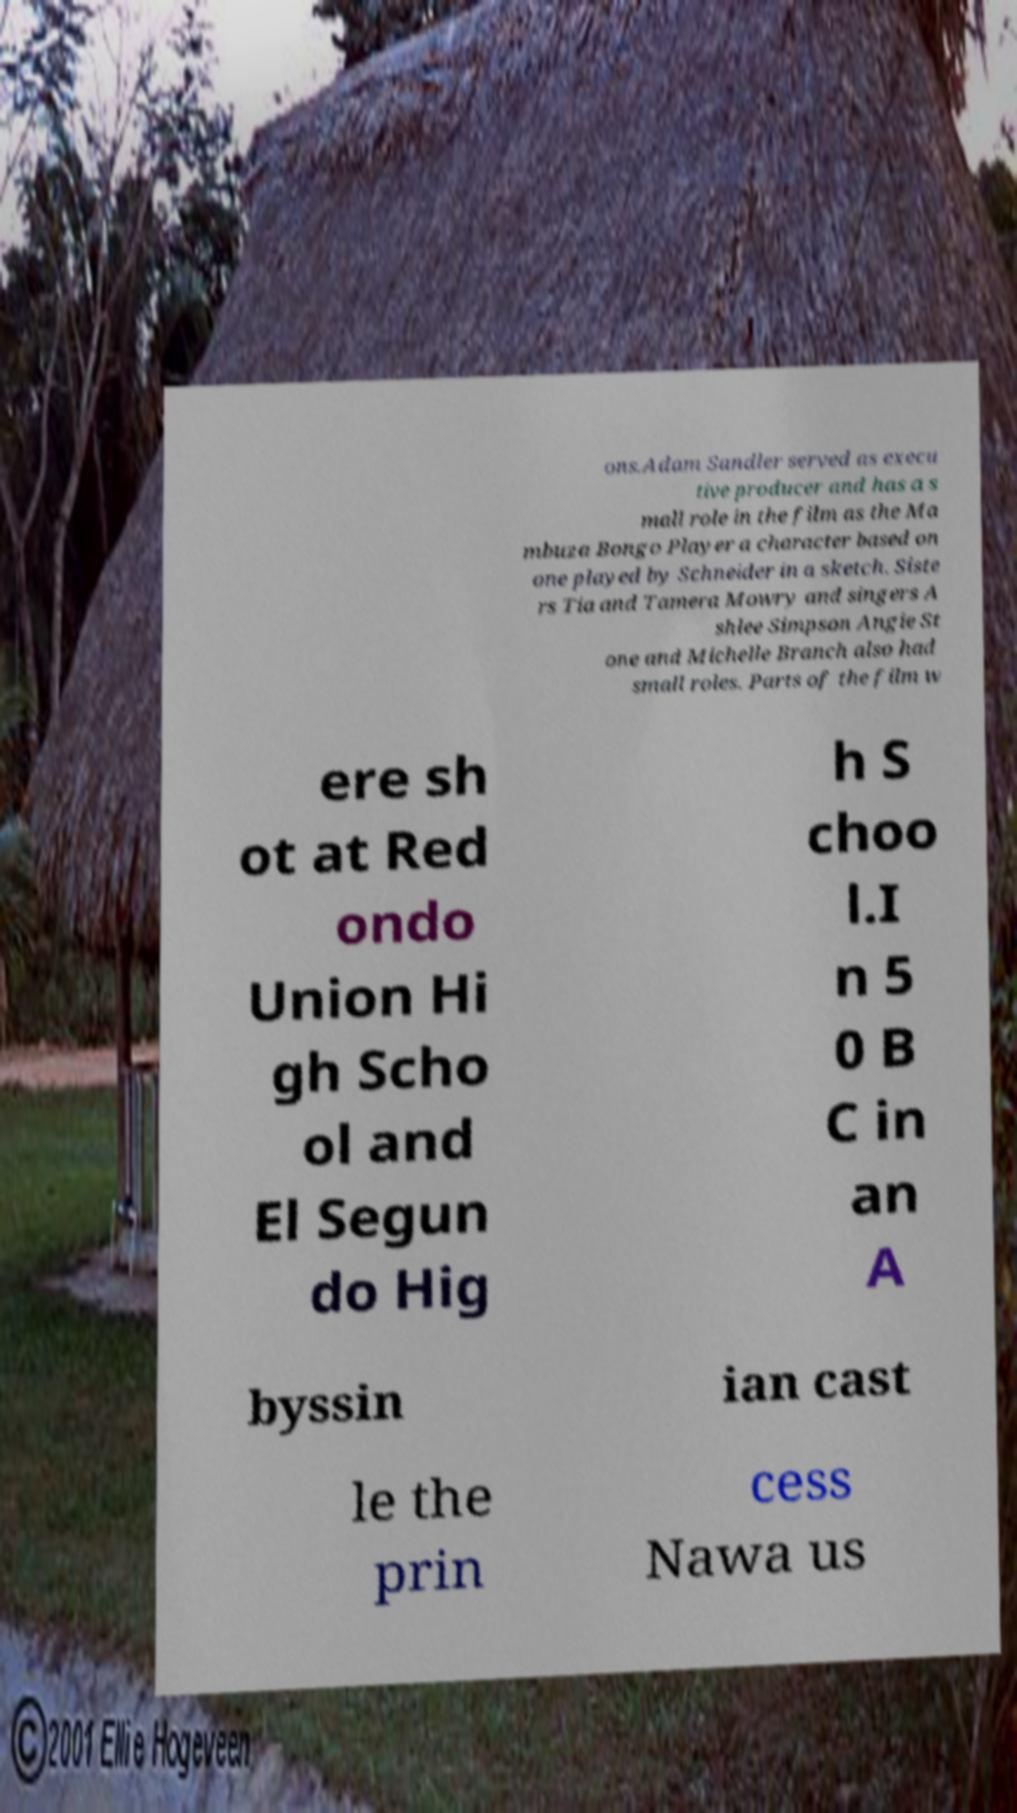Please identify and transcribe the text found in this image. ons.Adam Sandler served as execu tive producer and has a s mall role in the film as the Ma mbuza Bongo Player a character based on one played by Schneider in a sketch. Siste rs Tia and Tamera Mowry and singers A shlee Simpson Angie St one and Michelle Branch also had small roles. Parts of the film w ere sh ot at Red ondo Union Hi gh Scho ol and El Segun do Hig h S choo l.I n 5 0 B C in an A byssin ian cast le the prin cess Nawa us 